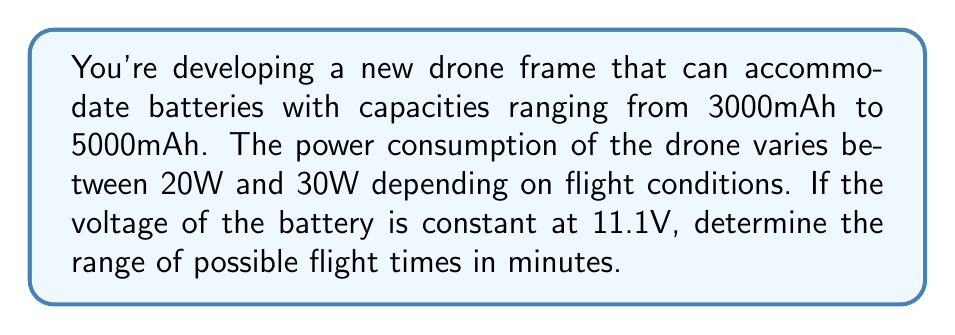Give your solution to this math problem. Let's approach this step-by-step:

1) First, we need to convert battery capacity from mAh to Wh:
   Energy (Wh) = Capacity (Ah) × Voltage (V)
   
   For 3000mAh: $3000 \text{ mAh} = 3 \text{ Ah}$
   $E_{min} = 3 \text{ Ah} \times 11.1 \text{ V} = 33.3 \text{ Wh}$
   
   For 5000mAh: $5000 \text{ mAh} = 5 \text{ Ah}$
   $E_{max} = 5 \text{ Ah} \times 11.1 \text{ V} = 55.5 \text{ Wh}$

2) Now, we can set up inequalities for the flight time (t) in hours:
   $$\frac{33.3 \text{ Wh}}{30 \text{ W}} \leq t \leq \frac{55.5 \text{ Wh}}{20 \text{ W}}$$

3) Simplify:
   $$1.11 \text{ h} \leq t \leq 2.775 \text{ h}$$

4) Convert to minutes:
   $$66.6 \text{ min} \leq t \leq 166.5 \text{ min}$$

5) Round to the nearest minute:
   $$67 \text{ min} \leq t \leq 167 \text{ min}$$

Therefore, the range of possible flight times is between 67 and 167 minutes.
Answer: $67 \text{ min} \leq t \leq 167 \text{ min}$ 